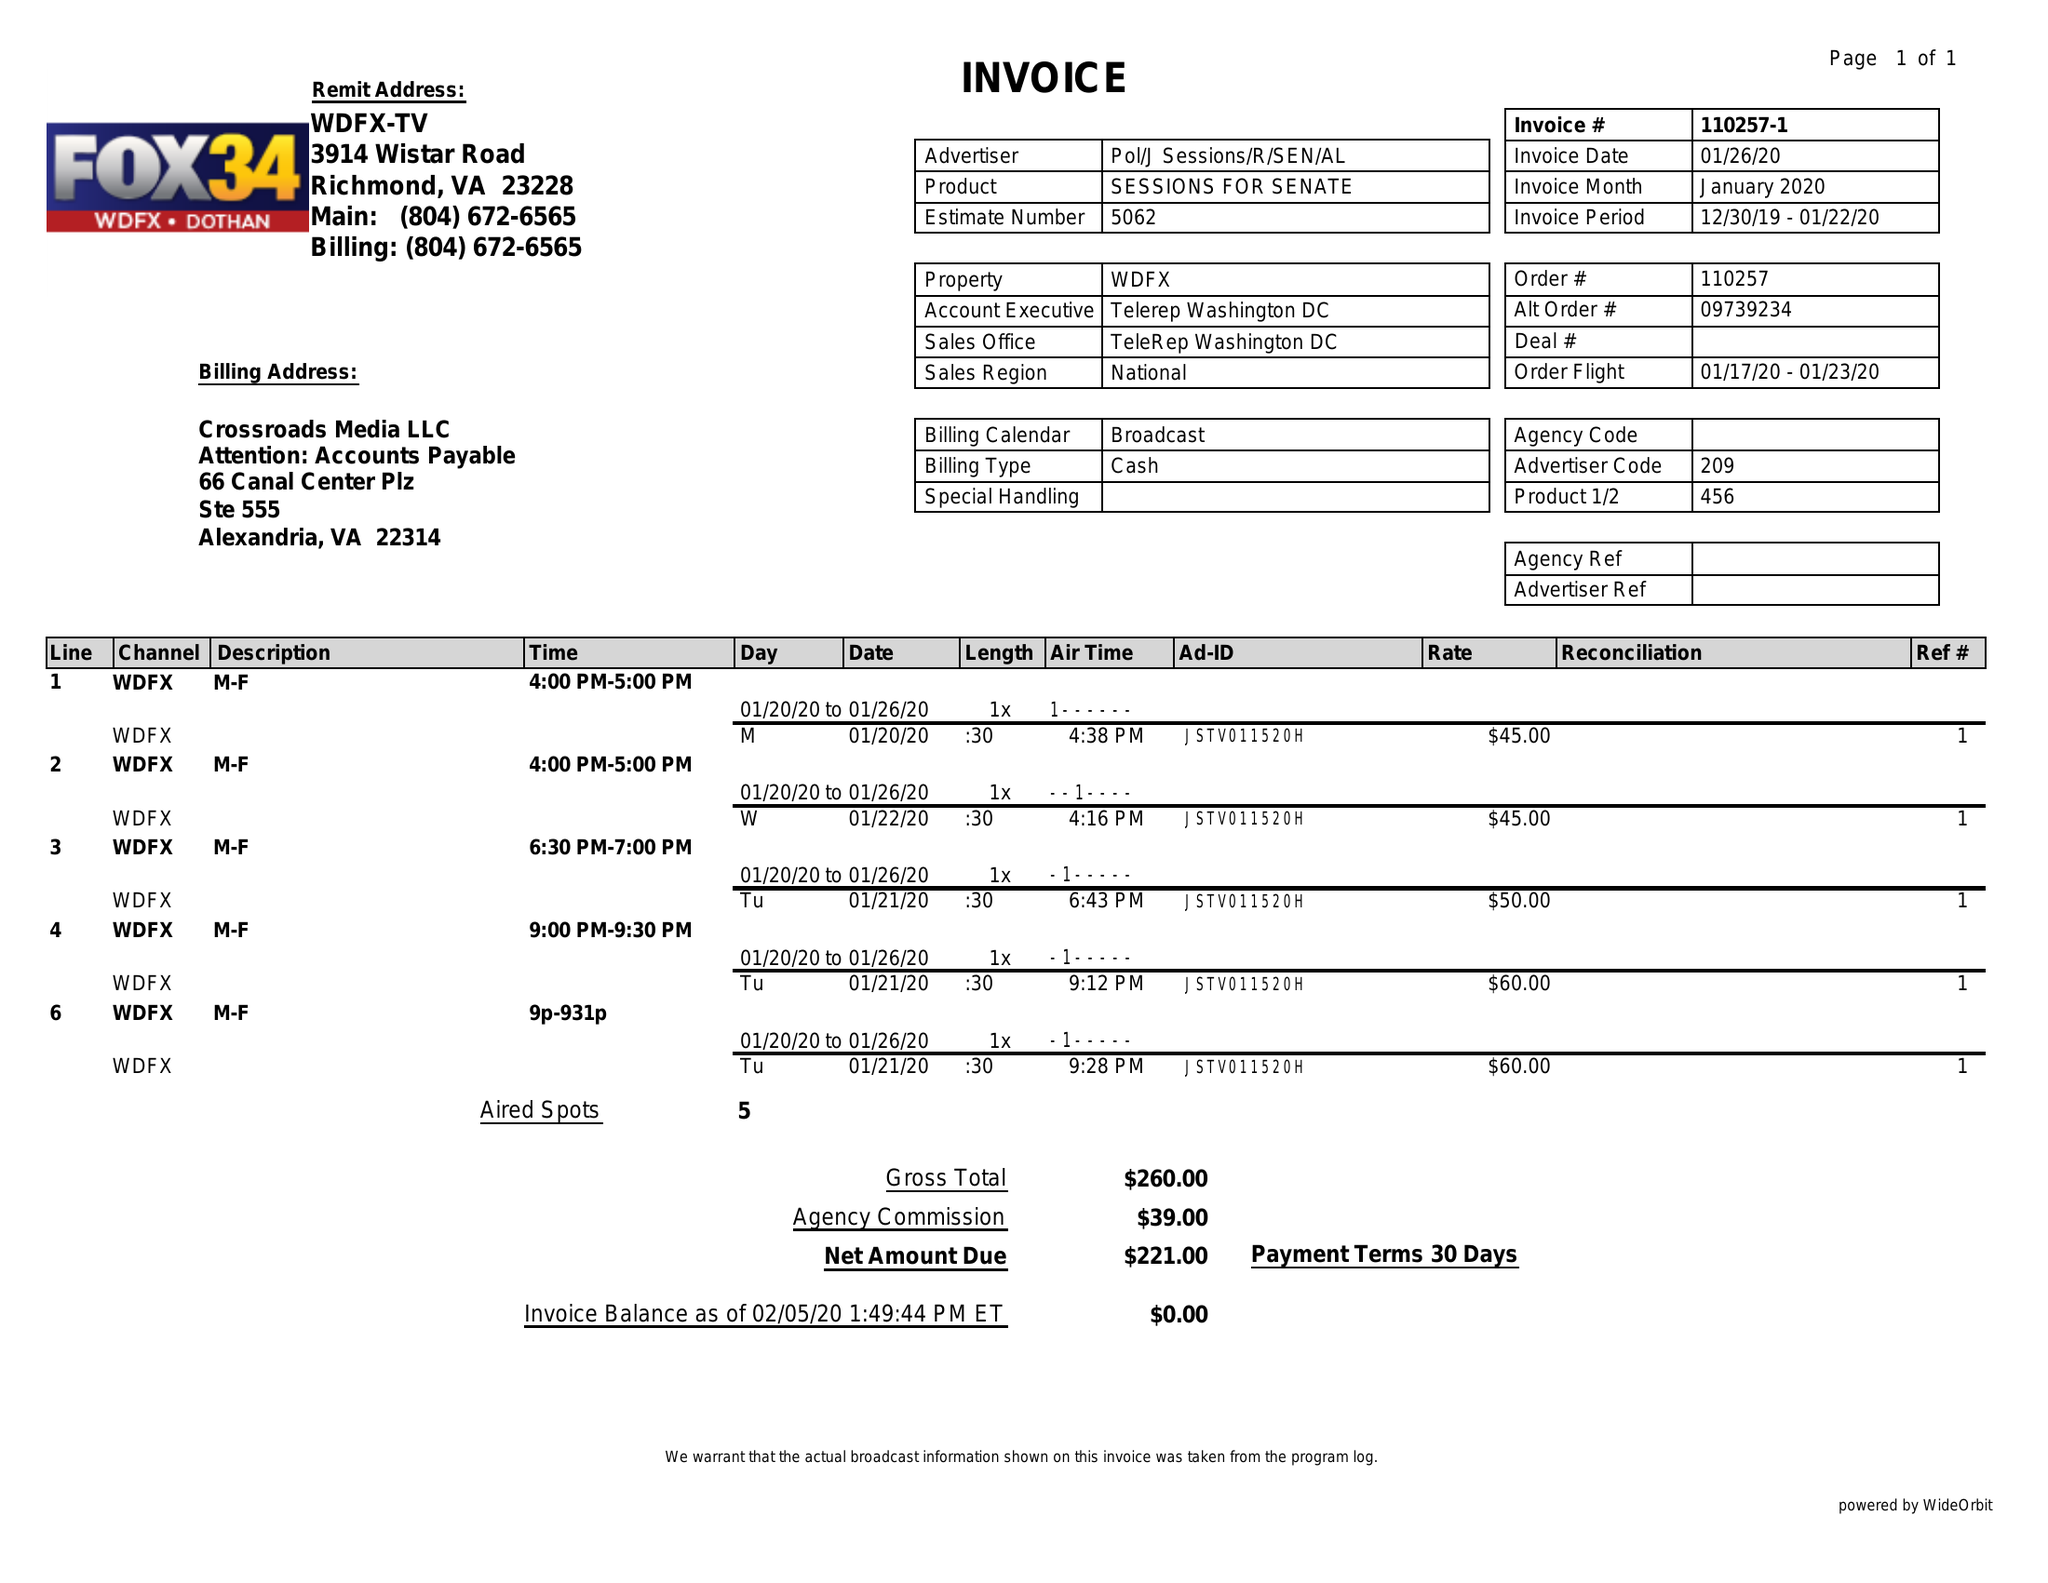What is the value for the flight_to?
Answer the question using a single word or phrase. 01/23/20 